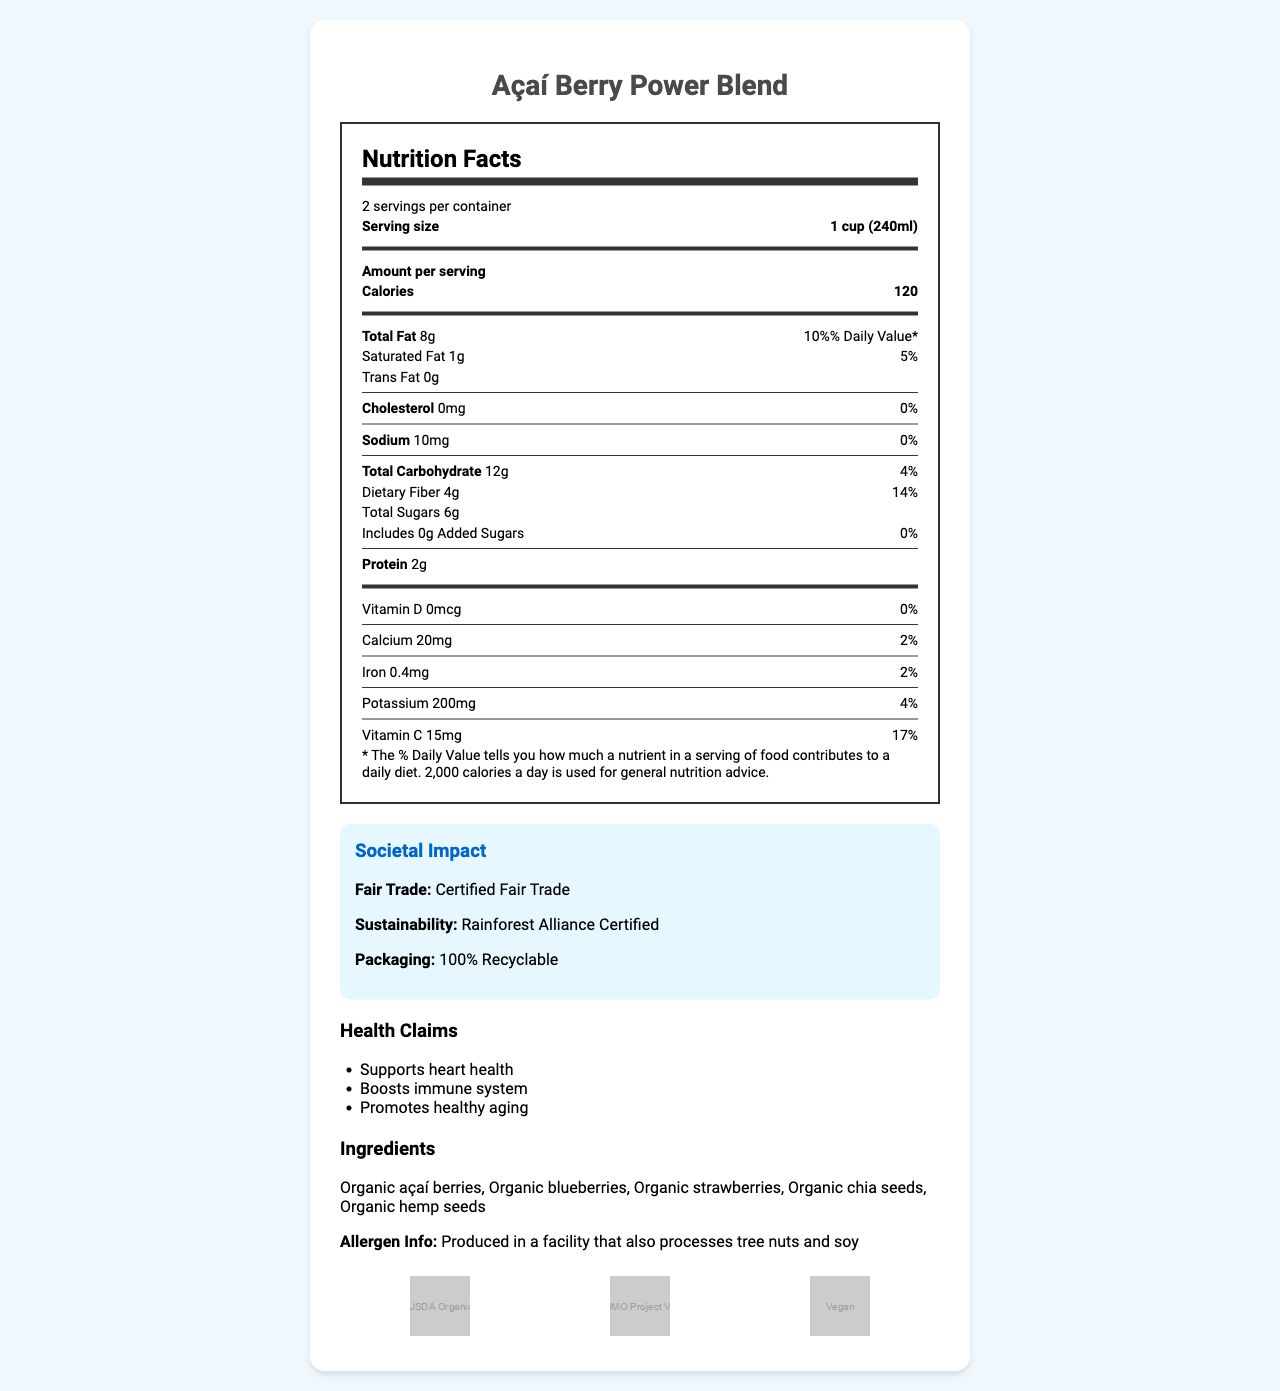What is the serving size of the Açaí Berry Power Blend? The serving size is specified in the document as "1 cup (240ml)".
Answer: 1 cup (240ml) How many calories are in one serving? The document states that each serving contains 120 calories.
Answer: 120 Which certifications does the Açaí Berry Power Blend have? The certifications are listed in the document as "USDA Organic, Non-GMO Project Verified, Vegan".
Answer: USDA Organic, Non-GMO Project Verified, Vegan What is the amount of dietary fiber per serving? Under the dietary fiber section, it shows "4g".
Answer: 4g What are the key ingredients of this product? The document lists the ingredients as "Organic açaí berries, Organic blueberries, Organic strawberries, Organic chia seeds, Organic hemp seeds".
Answer: Organic açaí berries, Organic blueberries, Organic strawberries, Organic chia seeds, Organic hemp seeds Which of the following health claims is NOT mentioned in the document? A. Supports heart health B. Boosts immune system C. Aids digestion D. Promotes healthy aging Only "Supports heart health", "Boosts immune system", and "Promotes healthy aging" are mentioned in the document.
Answer: C. Aids digestion What is the daily value percentage of Vitamin C in one serving? A. 17% B. 4% C. 10% D. 2% The document mentions that one serving provides 15mg of Vitamin C, which is 17% of the daily value.
Answer: A. 17% Is the Açaí Berry Power Blend high in antioxidants? The document specifies that the product is "High in anthocyanins and flavonoids", which are types of antioxidants.
Answer: Yes Does the Açaí Berry Power Blend contain any added sugars? The document indicates that there are "0g" of added sugars.
Answer: No Summarize the main features and claims of the Açaí Berry Power Blend. The document provides detailed information on the nutritional content, health claims, ingredients, allergen information, certifications, societal impact, consumer behavior influences, and market trends of the Açaí Berry Power Blend.
Answer: The Açaí Berry Power Blend is a nutrient-rich superfood with a serving size of 1 cup (240ml) and provides 120 calories per serving. It has multiple health claims such as supporting heart health, boosting the immune system, and promoting healthy aging. The blend contains key ingredients like organic açaí berries, blueberries, strawberries, chia seeds, and hemp seeds. It is certified USDA Organic, Non-GMO Project Verified, and Vegan. Additionally, it is fair trade certified, has sustainable sourcing, and uses 100% recyclable packaging. The product is marketed towards health-conscious millennials, fitness enthusiasts, and eco-friendly consumers, utilizing social media hashtags and celebrity endorsements to influence consumer behavior. What is the target demographic for the Açaí Berry Power Blend? The document lists these three groups as the target demographic.
Answer: Health-conscious millennials, fitness enthusiasts, eco-friendly consumers By what percentage is the global açaí market expected to grow annually from 2021-2026? The document states that the global açaí market is expected to grow at a compound annual growth rate (CAGR) of 15% from 2021-2026.
Answer: 15% CAGR What is the amount of cholesterol per serving? The document clearly lists "0mg" for cholesterol content.
Answer: 0mg Is the packaging of this product recyclable? The societal impact section indicates that the packaging is "100% Recyclable".
Answer: Yes Can this product be consumed by people with tree nut allergies? The document notes that the product is "Produced in a facility that also processes tree nuts and soy," which means there's a risk of cross-contamination. However, it doesn't specify if the product contains tree nuts itself.
Answer: Not enough information What are the wellness trends associated with the Açaí Berry Power Blend? The document includes these trends under the section on consumer behavior influence.
Answer: Plant-based diets, functional foods, gut health 